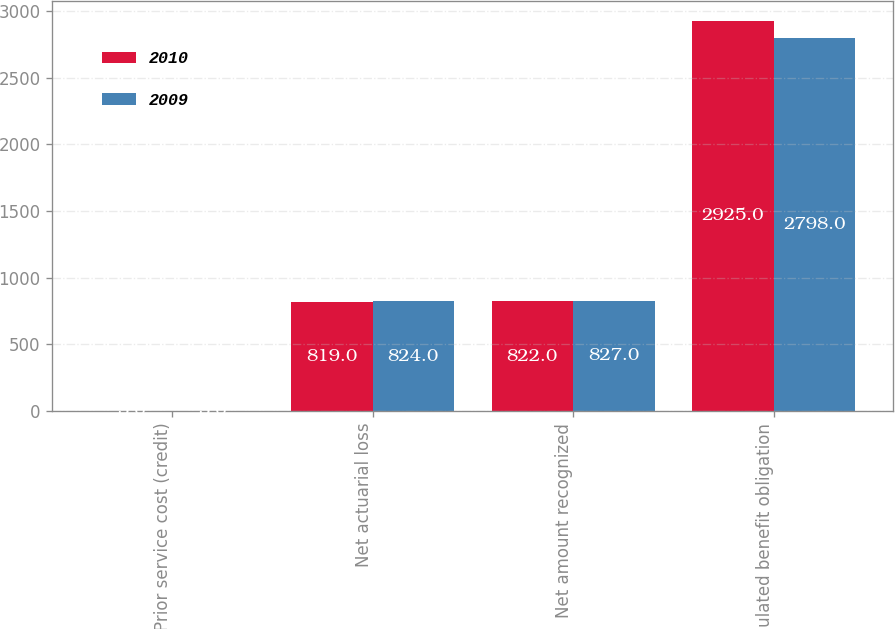Convert chart to OTSL. <chart><loc_0><loc_0><loc_500><loc_500><stacked_bar_chart><ecel><fcel>Prior service cost (credit)<fcel>Net actuarial loss<fcel>Net amount recognized<fcel>Accumulated benefit obligation<nl><fcel>2010<fcel>3<fcel>819<fcel>822<fcel>2925<nl><fcel>2009<fcel>3<fcel>824<fcel>827<fcel>2798<nl></chart> 